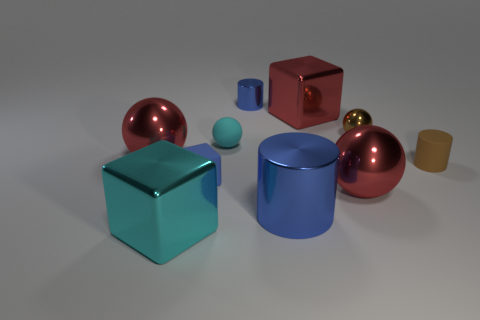Subtract all metallic balls. How many balls are left? 1 Subtract all red balls. How many balls are left? 2 Subtract all blue cylinders. Subtract all tiny rubber things. How many objects are left? 5 Add 7 large blue things. How many large blue things are left? 8 Add 1 tiny brown matte cylinders. How many tiny brown matte cylinders exist? 2 Subtract 0 gray spheres. How many objects are left? 10 Subtract all blocks. How many objects are left? 7 Subtract 2 spheres. How many spheres are left? 2 Subtract all green spheres. Subtract all cyan blocks. How many spheres are left? 4 Subtract all purple cubes. How many brown cylinders are left? 1 